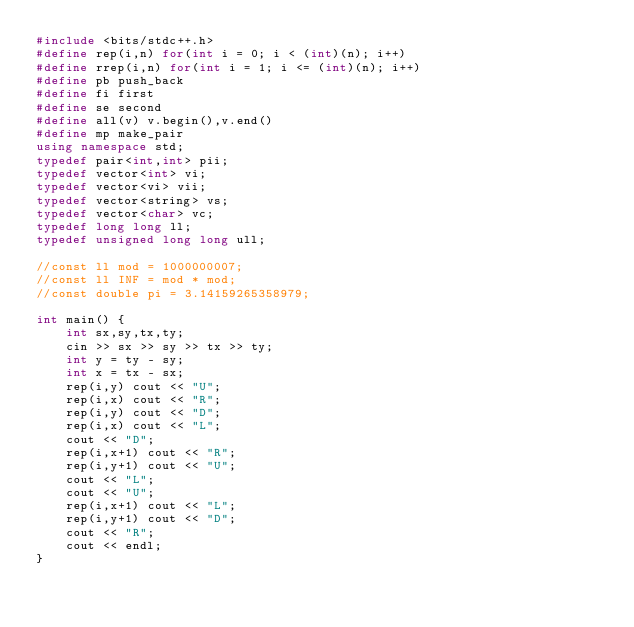<code> <loc_0><loc_0><loc_500><loc_500><_C++_>#include <bits/stdc++.h>
#define rep(i,n) for(int i = 0; i < (int)(n); i++) 
#define rrep(i,n) for(int i = 1; i <= (int)(n); i++) 
#define pb push_back
#define fi first
#define se second
#define all(v) v.begin(),v.end()
#define mp make_pair
using namespace std;
typedef pair<int,int> pii;
typedef vector<int> vi;
typedef vector<vi> vii;
typedef vector<string> vs;
typedef vector<char> vc;
typedef long long ll;
typedef unsigned long long ull;

//const ll mod = 1000000007;
//const ll INF = mod * mod;
//const double pi = 3.14159265358979;

int main() {
    int sx,sy,tx,ty;
    cin >> sx >> sy >> tx >> ty;
    int y = ty - sy;
    int x = tx - sx;
    rep(i,y) cout << "U";
    rep(i,x) cout << "R";
    rep(i,y) cout << "D";
    rep(i,x) cout << "L";
    cout << "D";
    rep(i,x+1) cout << "R";
    rep(i,y+1) cout << "U";
    cout << "L";
    cout << "U";
    rep(i,x+1) cout << "L";
    rep(i,y+1) cout << "D";
    cout << "R";
    cout << endl;
}</code> 